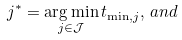<formula> <loc_0><loc_0><loc_500><loc_500>j ^ { * } = \underset { j \in \mathcal { J } } { \arg \min } \, t _ { \min , j } , \, a n d</formula> 